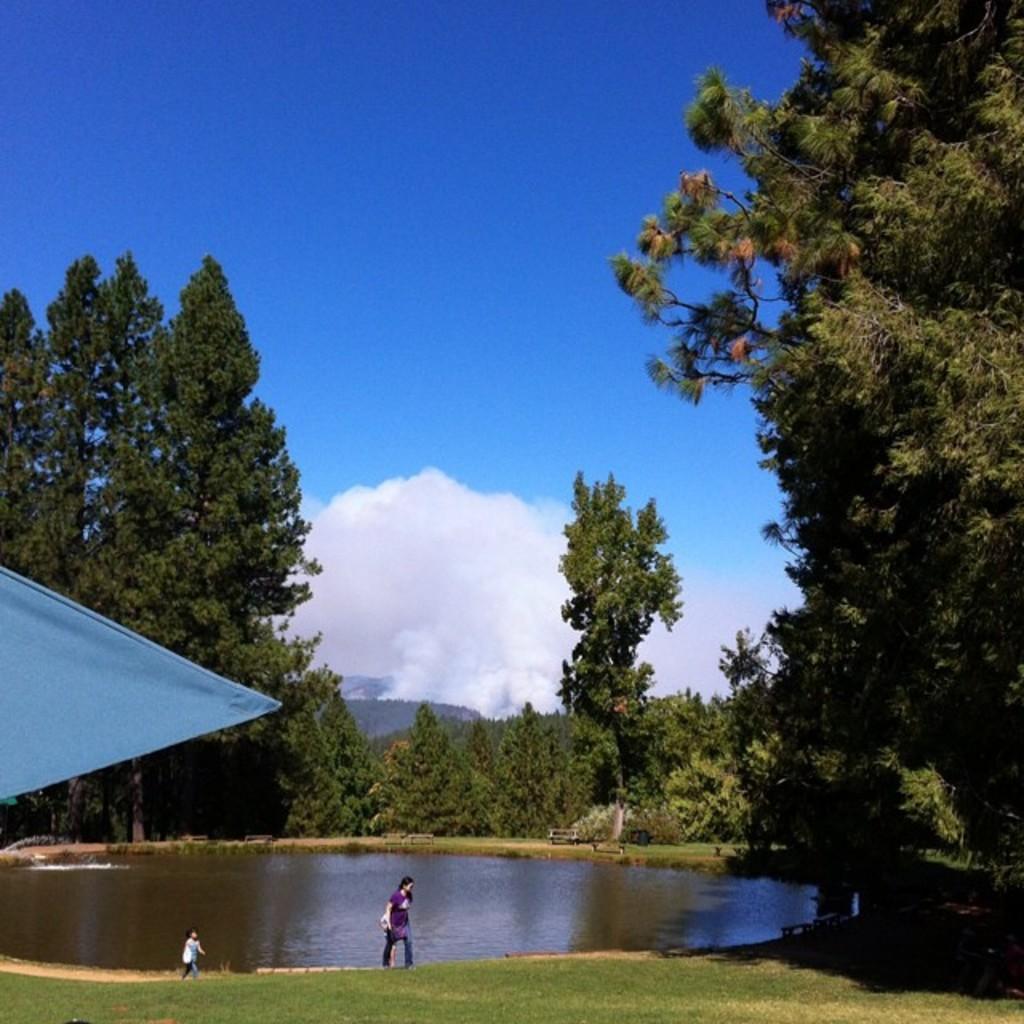Could you give a brief overview of what you see in this image? In this image, we can see two persons are walking. At the bottom, there is a grass and water. Here we can see cloth. Background there are so many trees, benches, plants, hill, smoke and sky. 